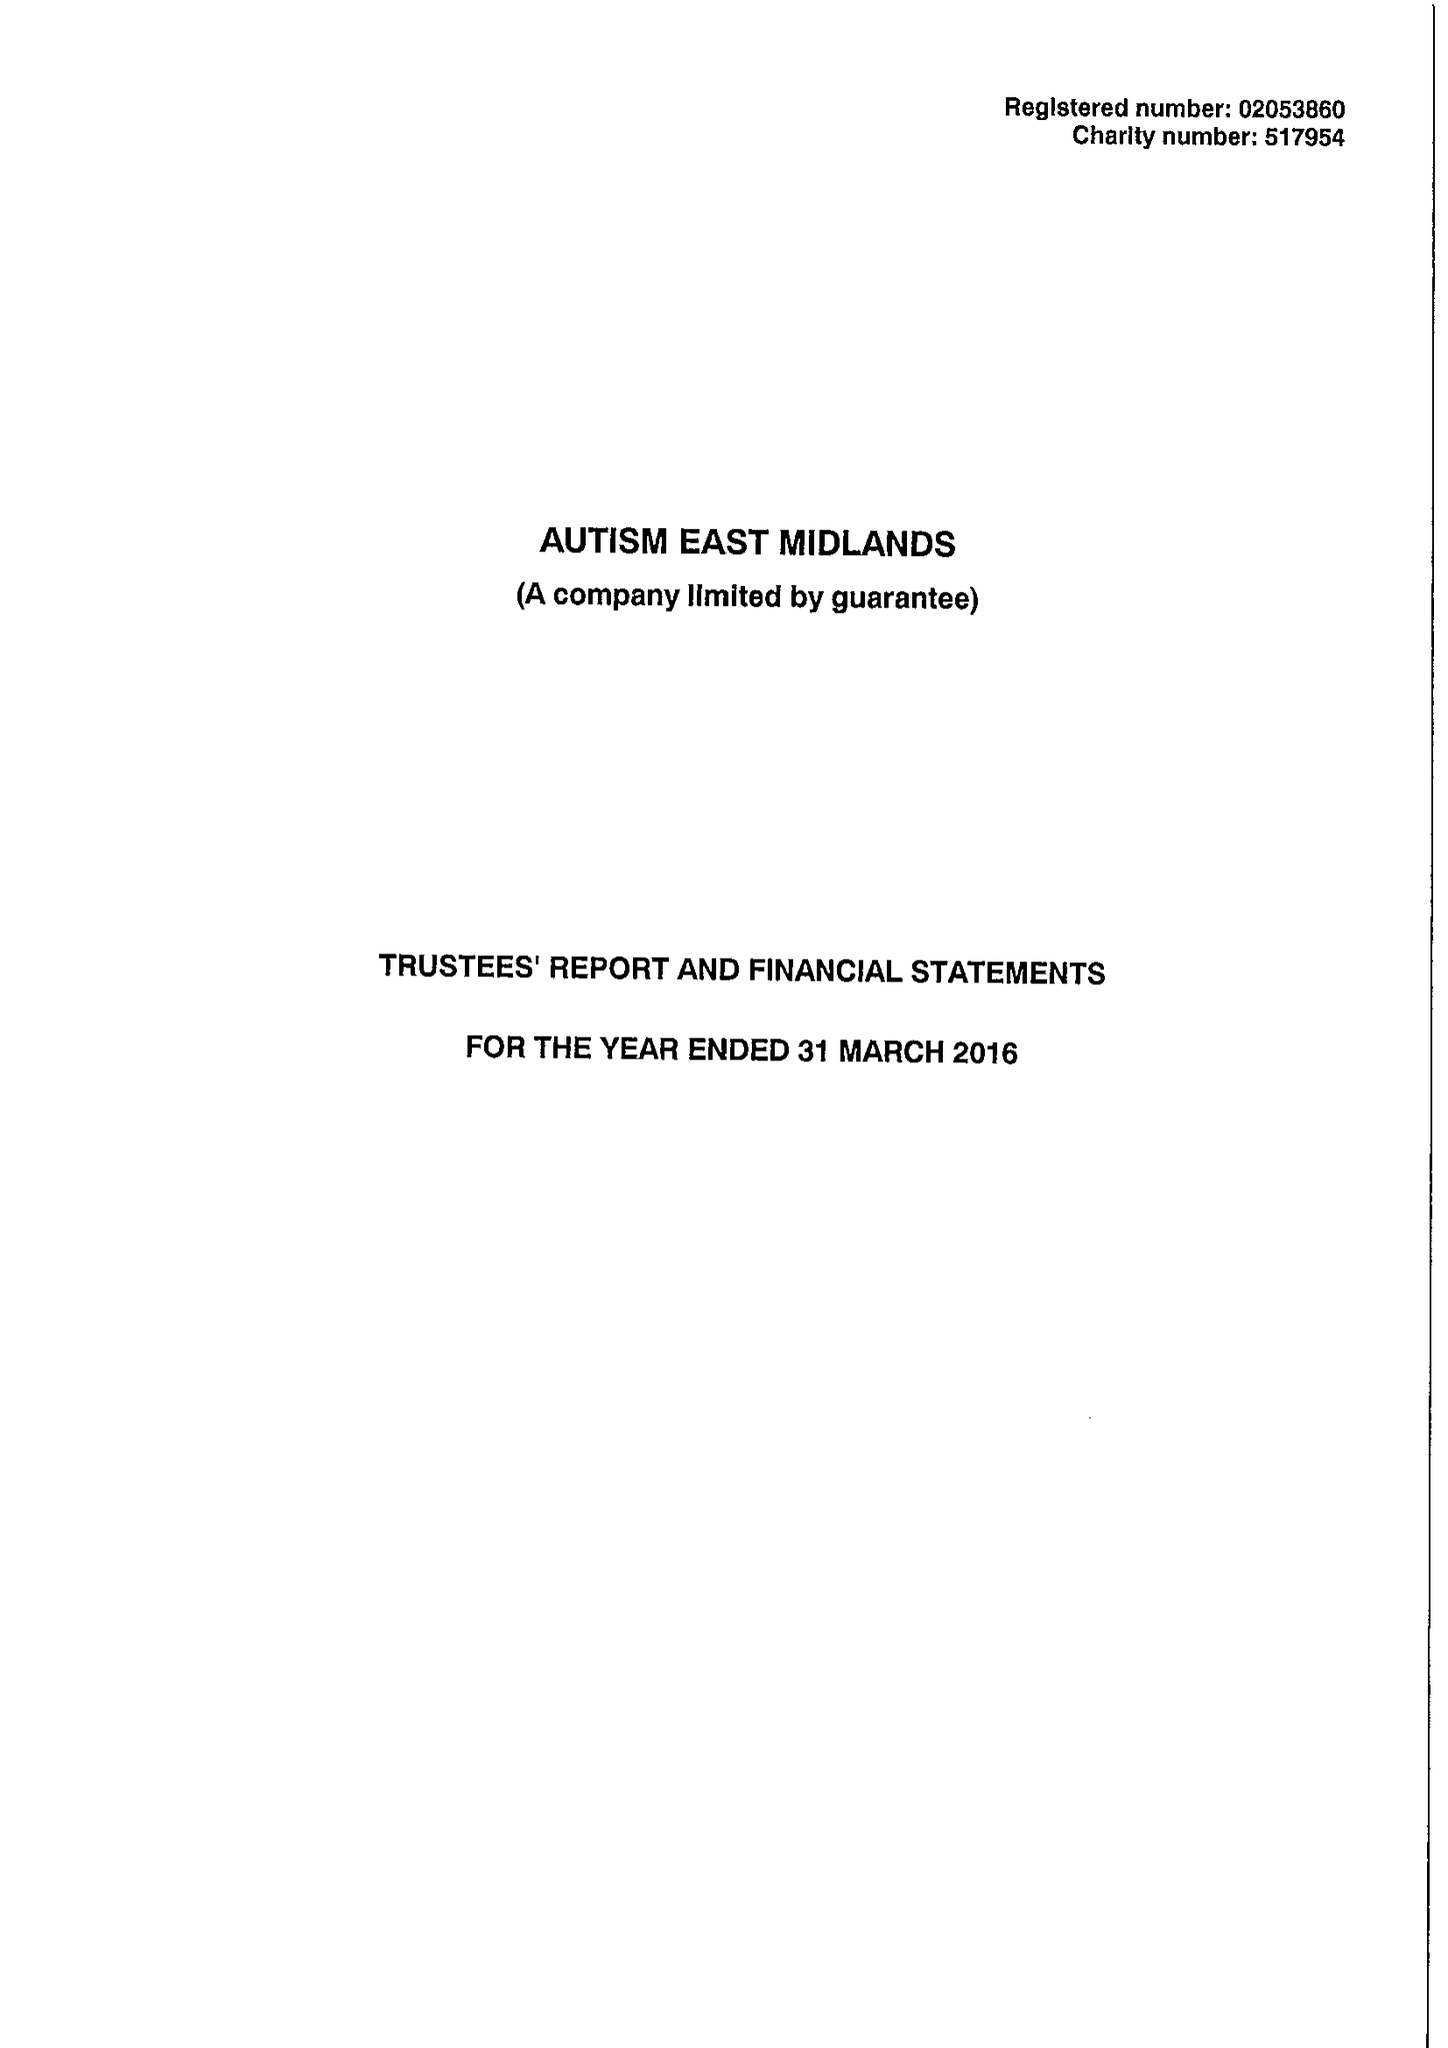What is the value for the address__post_town?
Answer the question using a single word or phrase. WORKSOP 